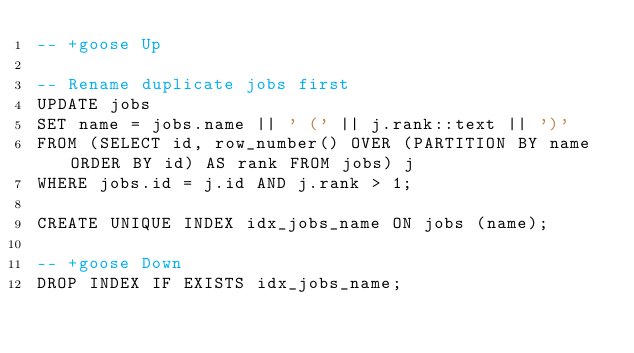<code> <loc_0><loc_0><loc_500><loc_500><_SQL_>-- +goose Up

-- Rename duplicate jobs first
UPDATE jobs
SET name = jobs.name || ' (' || j.rank::text || ')'
FROM (SELECT id, row_number() OVER (PARTITION BY name ORDER BY id) AS rank FROM jobs) j
WHERE jobs.id = j.id AND j.rank > 1;

CREATE UNIQUE INDEX idx_jobs_name ON jobs (name);

-- +goose Down
DROP INDEX IF EXISTS idx_jobs_name;</code> 